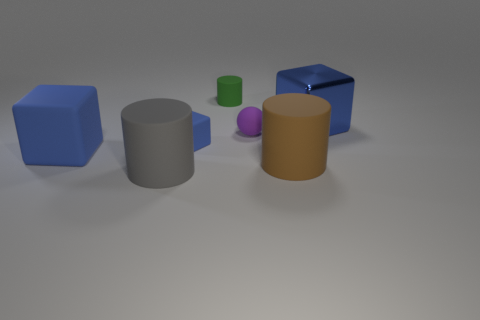Subtract all blue blocks. How many were subtracted if there are1blue blocks left? 2 Subtract all small blue cubes. How many cubes are left? 2 Add 2 big objects. How many objects exist? 9 Add 4 large shiny objects. How many large shiny objects are left? 5 Add 4 small things. How many small things exist? 7 Subtract 1 gray cylinders. How many objects are left? 6 Subtract all blocks. How many objects are left? 4 Subtract 2 cylinders. How many cylinders are left? 1 Subtract all brown cubes. Subtract all cyan cylinders. How many cubes are left? 3 Subtract all large purple metallic spheres. Subtract all green rubber cylinders. How many objects are left? 6 